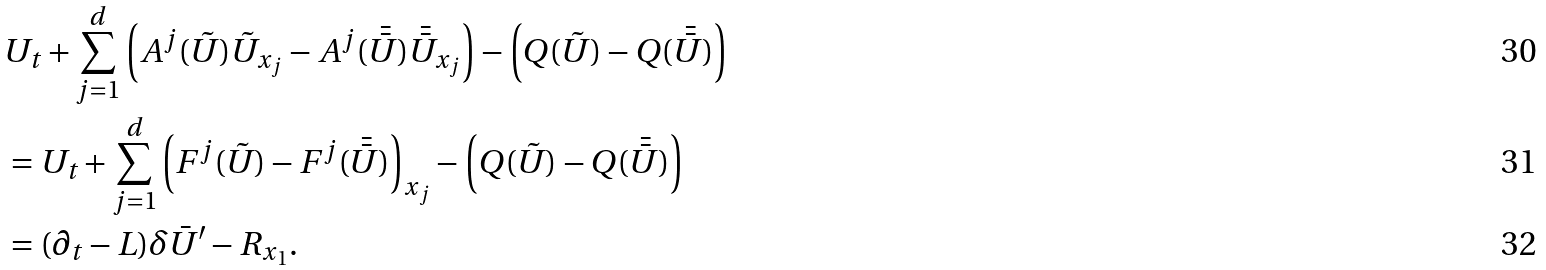Convert formula to latex. <formula><loc_0><loc_0><loc_500><loc_500>& U _ { t } + \sum _ { j = 1 } ^ { d } \left ( A ^ { j } ( \tilde { U } ) \tilde { U } _ { x _ { j } } - A ^ { j } ( \bar { \bar { U } } ) \bar { \bar { U } } _ { x _ { j } } \right ) - \left ( Q ( \tilde { U } ) - Q ( \bar { \bar { U } } ) \right ) \\ & = U _ { t } + \sum _ { j = 1 } ^ { d } \left ( F ^ { j } ( \tilde { U } ) - F ^ { j } ( \bar { \bar { U } } ) \right ) _ { x _ { j } } - \left ( Q ( \tilde { U } ) - Q ( \bar { \bar { U } } ) \right ) \\ & = ( \partial _ { t } - L ) \delta \bar { U } ^ { \prime } - R _ { x _ { 1 } } .</formula> 